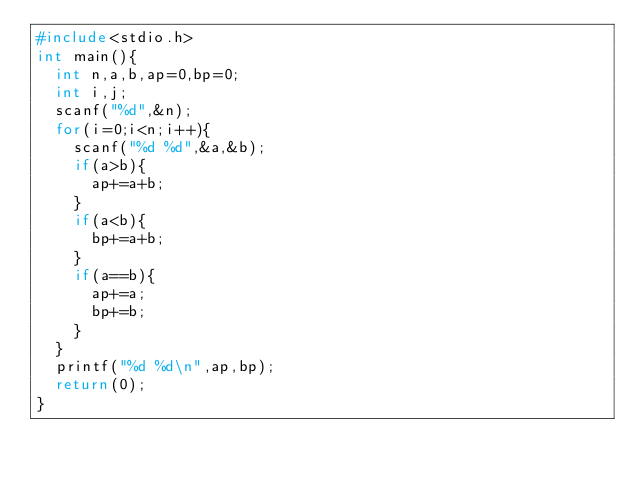<code> <loc_0><loc_0><loc_500><loc_500><_C++_>#include<stdio.h>
int main(){
  int n,a,b,ap=0,bp=0;
  int i,j;
  scanf("%d",&n);
  for(i=0;i<n;i++){
    scanf("%d %d",&a,&b);
    if(a>b){
      ap+=a+b;
    }
    if(a<b){
      bp+=a+b;
    }
    if(a==b){
      ap+=a;
      bp+=b;
    }
  }
  printf("%d %d\n",ap,bp);
  return(0);
}</code> 